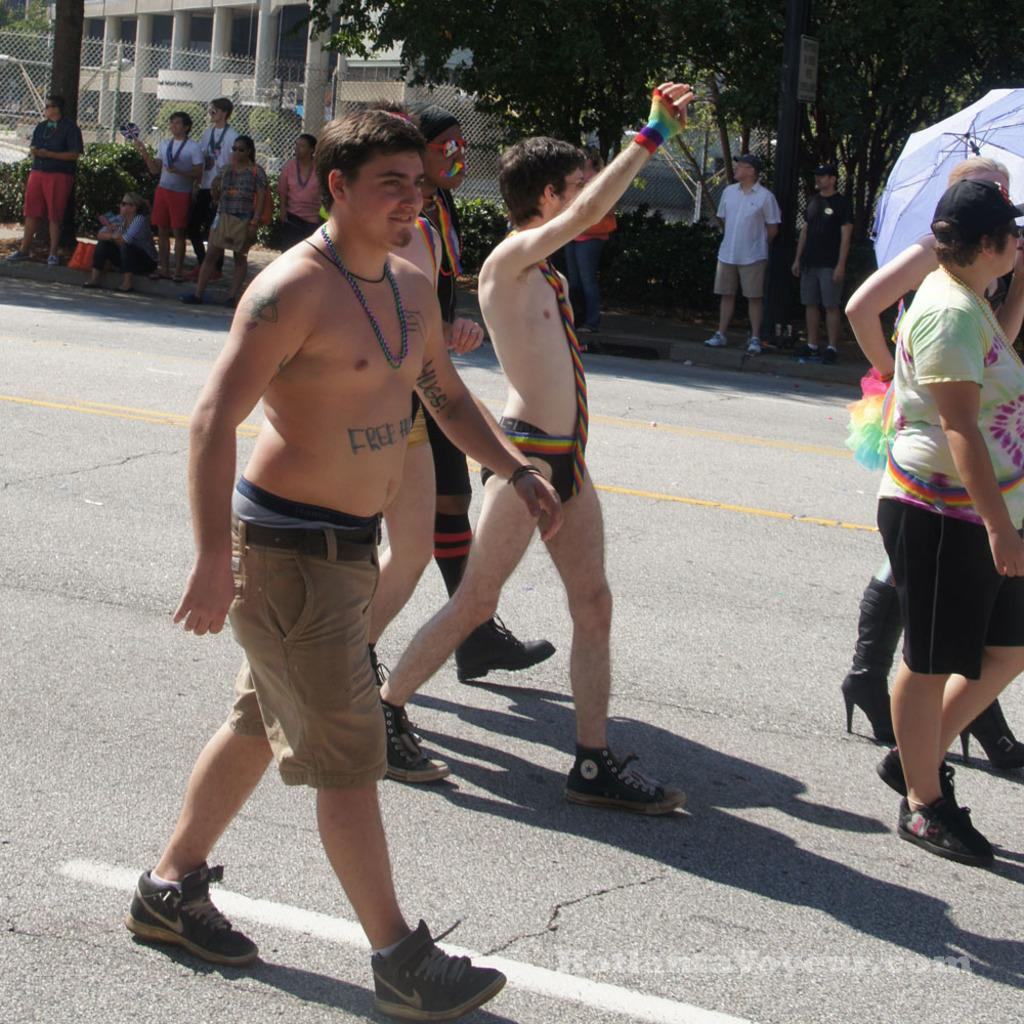What are the people in the image doing? The people in the image are walking on the road. Are there any other people visible in the image? Yes, there are people visible on the side of the road. What type of vegetation can be seen in the image? There are trees in the image. What type of structures are present in the image? There are buildings in the image. Can you see a tank driving through the hole in the image? There is no tank or hole present in the image. Is there a squirrel visible in the image? There is no squirrel visible in the image. 